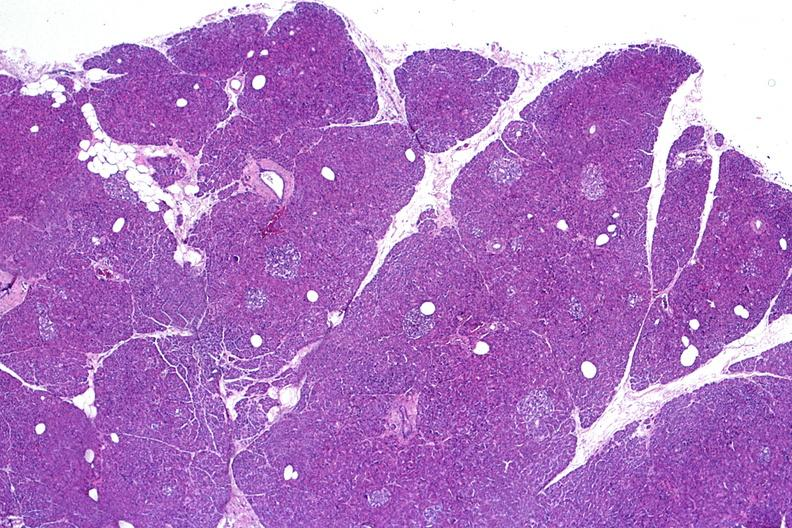does infarction secondary to shock show normal pancreas?
Answer the question using a single word or phrase. No 